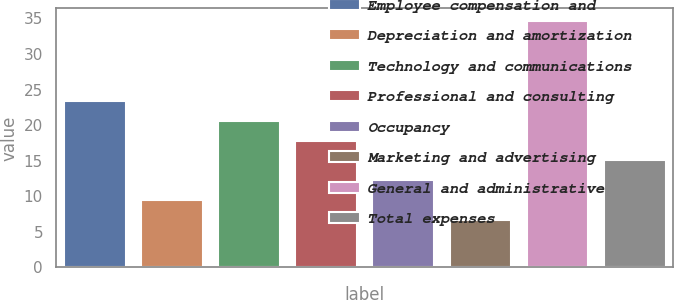Convert chart to OTSL. <chart><loc_0><loc_0><loc_500><loc_500><bar_chart><fcel>Employee compensation and<fcel>Depreciation and amortization<fcel>Technology and communications<fcel>Professional and consulting<fcel>Occupancy<fcel>Marketing and advertising<fcel>General and administrative<fcel>Total expenses<nl><fcel>23.46<fcel>9.41<fcel>20.65<fcel>17.84<fcel>12.22<fcel>6.6<fcel>34.7<fcel>15.03<nl></chart> 